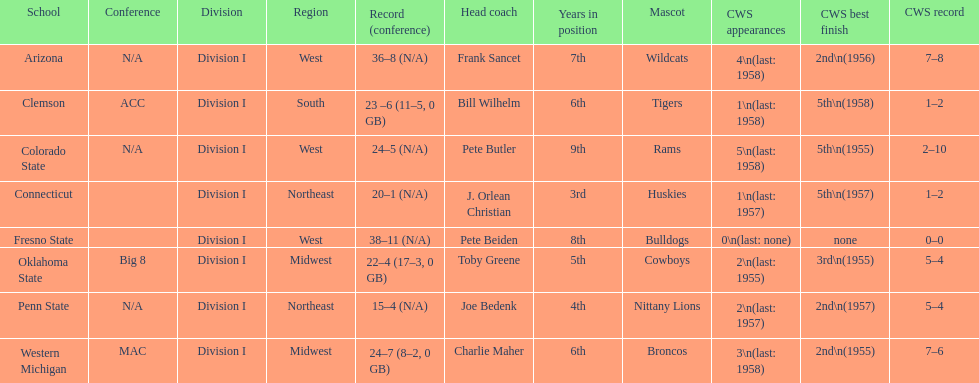How many teams had their cws best finish in 1955? 3. 